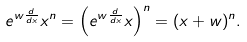<formula> <loc_0><loc_0><loc_500><loc_500>e ^ { w \frac { d } { d x } } x ^ { n } = \left ( e ^ { w \frac { d } { d x } } x \right ) ^ { n } = ( x + w ) ^ { n } .</formula> 